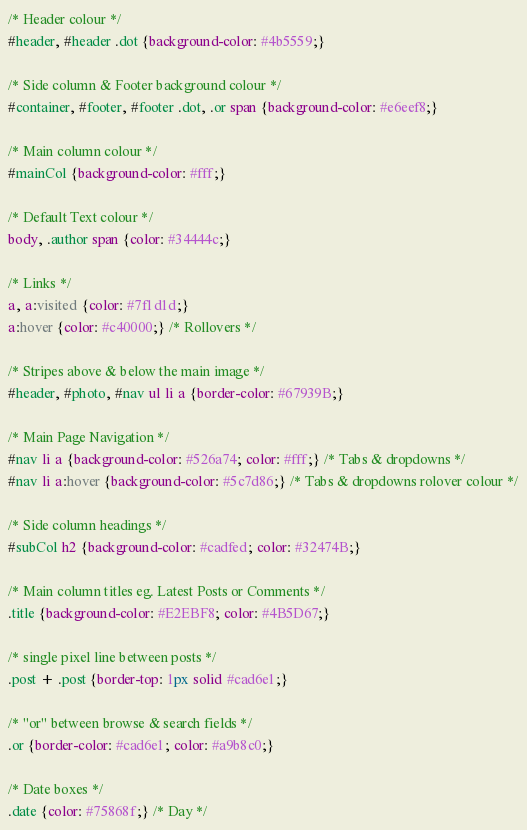Convert code to text. <code><loc_0><loc_0><loc_500><loc_500><_CSS_>/* Header colour */
#header, #header .dot {background-color: #4b5559;}

/* Side column & Footer background colour */
#container, #footer, #footer .dot, .or span {background-color: #e6eef8;}

/* Main column colour */
#mainCol {background-color: #fff;}

/* Default Text colour */
body, .author span {color: #34444c;}

/* Links */
a, a:visited {color: #7f1d1d;}
a:hover {color: #c40000;} /* Rollovers */

/* Stripes above & below the main image */
#header, #photo, #nav ul li a {border-color: #67939B;}

/* Main Page Navigation */
#nav li a {background-color: #526a74; color: #fff;} /* Tabs & dropdowns */
#nav li a:hover {background-color: #5c7d86;} /* Tabs & dropdowns rolover colour */

/* Side column headings */
#subCol h2 {background-color: #cadfed; color: #32474B;}

/* Main column titles eg. Latest Posts or Comments */
.title {background-color: #E2EBF8; color: #4B5D67;}

/* single pixel line between posts */
.post + .post {border-top: 1px solid #cad6e1;}

/* "or" between browse & search fields */ 
.or {border-color: #cad6e1; color: #a9b8c0;}

/* Date boxes */
.date {color: #75868f;} /* Day */</code> 